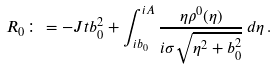Convert formula to latex. <formula><loc_0><loc_0><loc_500><loc_500>R _ { 0 } \colon = - J t b _ { 0 } ^ { 2 } + \int _ { i b _ { 0 } } ^ { i A } \frac { \eta \rho ^ { 0 } ( \eta ) } { i \sigma \sqrt { \eta ^ { 2 } + b _ { 0 } ^ { 2 } } } \, d \eta \, .</formula> 